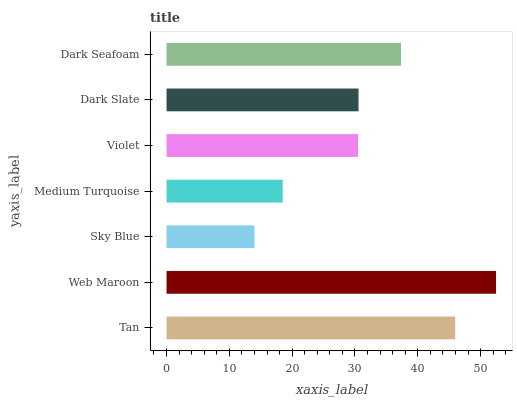Is Sky Blue the minimum?
Answer yes or no. Yes. Is Web Maroon the maximum?
Answer yes or no. Yes. Is Web Maroon the minimum?
Answer yes or no. No. Is Sky Blue the maximum?
Answer yes or no. No. Is Web Maroon greater than Sky Blue?
Answer yes or no. Yes. Is Sky Blue less than Web Maroon?
Answer yes or no. Yes. Is Sky Blue greater than Web Maroon?
Answer yes or no. No. Is Web Maroon less than Sky Blue?
Answer yes or no. No. Is Dark Slate the high median?
Answer yes or no. Yes. Is Dark Slate the low median?
Answer yes or no. Yes. Is Dark Seafoam the high median?
Answer yes or no. No. Is Web Maroon the low median?
Answer yes or no. No. 